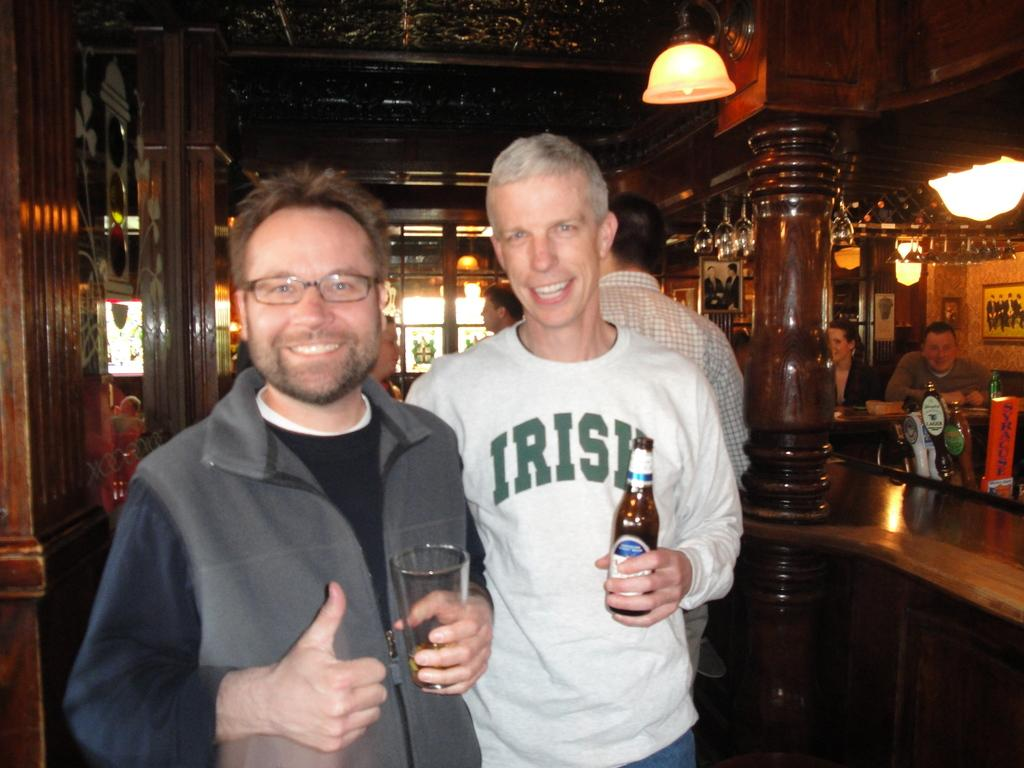Who is standing on the left side of the image? There is a man standing on the left side of the image. What is the man holding in the image? The man is holding a wine glass. Who is standing in the middle of the image? There is a boy standing in the middle of the image. What is the boy holding in the image? The boy is holding a beer bottle. What can be seen at the top of the image? There is a light visible at the top of the image. What type of advice is the man giving to the boy in the image? There is no indication in the image that the man is giving advice to the boy. 